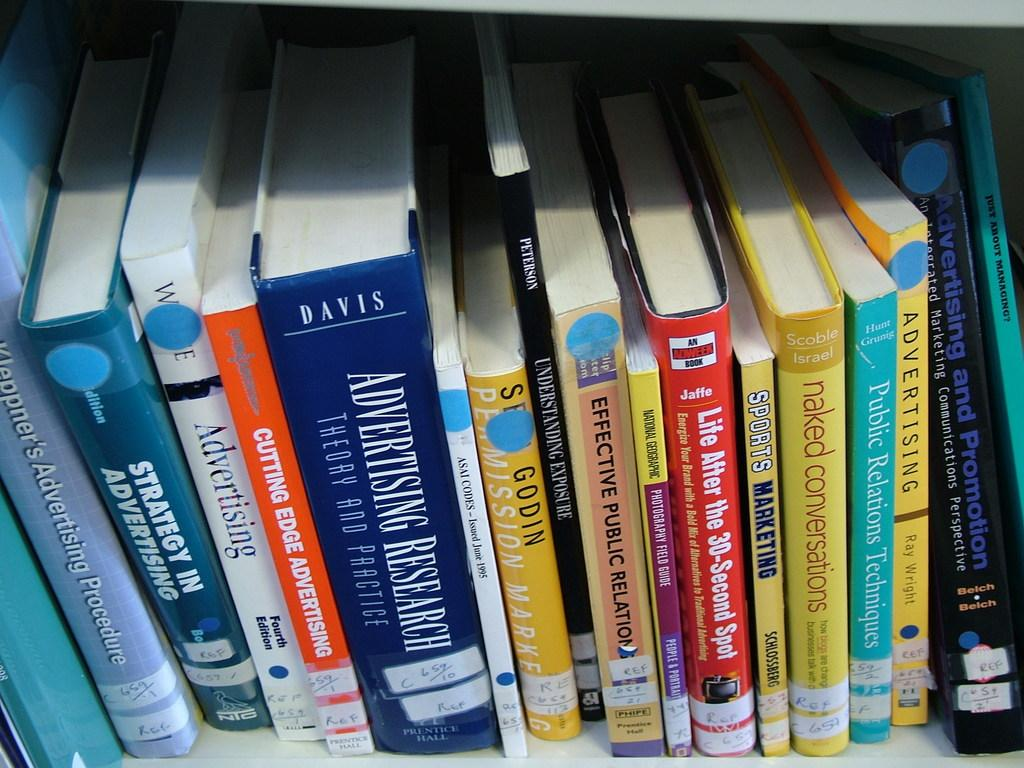<image>
Create a compact narrative representing the image presented. A shelf full of books some of which are about advertising. 